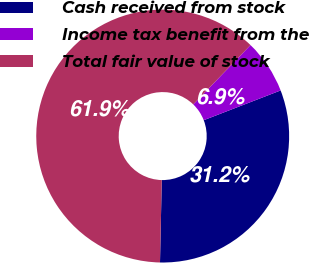Convert chart to OTSL. <chart><loc_0><loc_0><loc_500><loc_500><pie_chart><fcel>Cash received from stock<fcel>Income tax benefit from the<fcel>Total fair value of stock<nl><fcel>31.22%<fcel>6.91%<fcel>61.88%<nl></chart> 